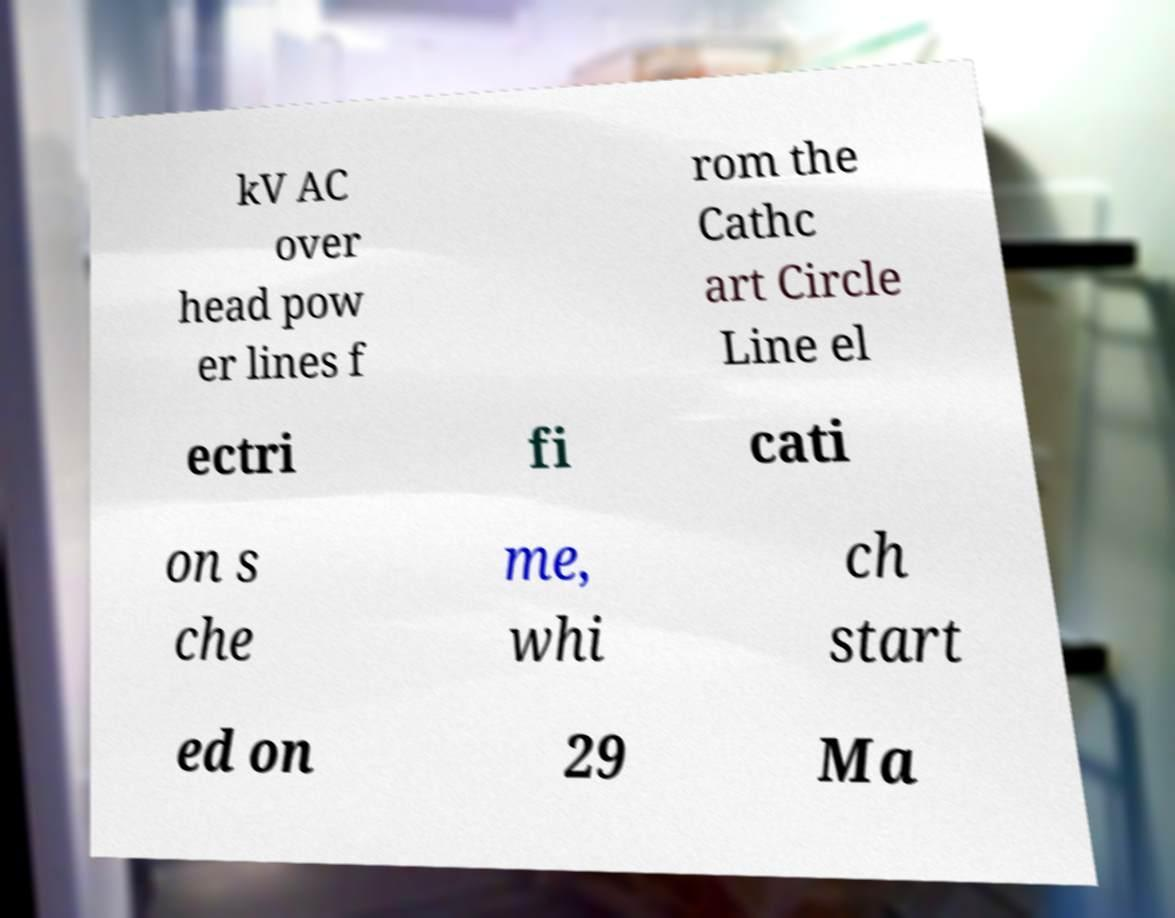Please read and relay the text visible in this image. What does it say? kV AC over head pow er lines f rom the Cathc art Circle Line el ectri fi cati on s che me, whi ch start ed on 29 Ma 